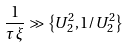Convert formula to latex. <formula><loc_0><loc_0><loc_500><loc_500>\frac { 1 } { \tau \, \xi } \gg \left \{ U _ { 2 } ^ { 2 } , 1 / U _ { 2 } ^ { 2 } \right \}</formula> 